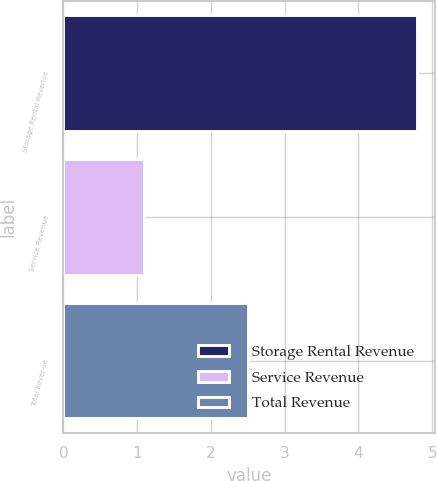Convert chart to OTSL. <chart><loc_0><loc_0><loc_500><loc_500><bar_chart><fcel>Storage Rental Revenue<fcel>Service Revenue<fcel>Total Revenue<nl><fcel>4.8<fcel>1.1<fcel>2.5<nl></chart> 